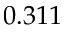Convert formula to latex. <formula><loc_0><loc_0><loc_500><loc_500>0 . 3 1 1</formula> 